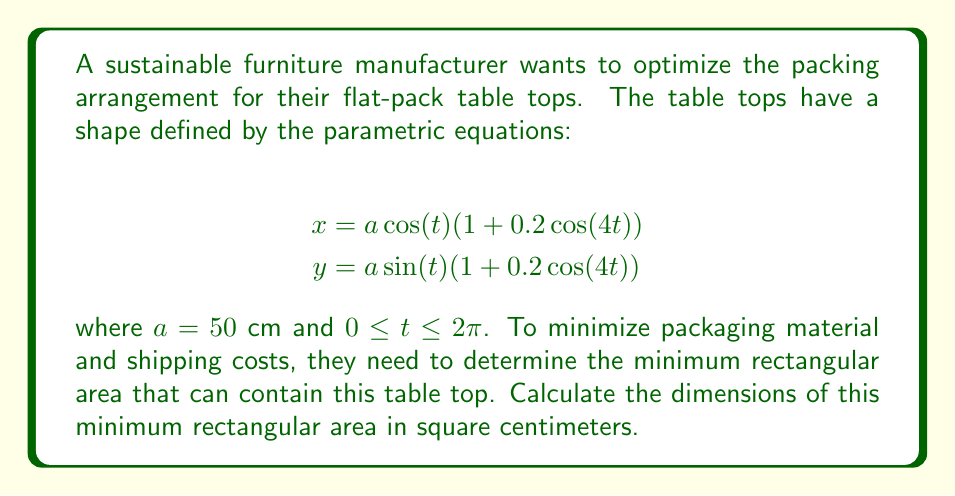Could you help me with this problem? To solve this problem, we need to find the maximum values of x and y, which will give us the width and height of the smallest rectangle that can contain the table top.

1. For the x-coordinate:
   The maximum value occurs when $\cos(t) = \pm 1$ and $\cos(4t) = 1$
   $$x_{max} = a(1 + 0.2) = 50(1.2) = 60\text{ cm}$$

2. For the y-coordinate:
   The maximum value occurs when $\sin(t) = \pm 1$ and $\cos(4t) = 1$
   $$y_{max} = a(1 + 0.2) = 50(1.2) = 60\text{ cm}$$

3. The minimum rectangle that can contain this shape is a square with sides of length 120 cm (twice the maximum value in each direction).

4. Calculate the area of this square:
   $$\text{Area} = 120 \text{ cm} \times 120 \text{ cm} = 14,400 \text{ cm}^2$$

This arrangement ensures the most efficient use of packaging material while securely containing the table top, aligning with the company's sustainability goals.
Answer: The minimum rectangular area to contain the table top is 14,400 cm². 